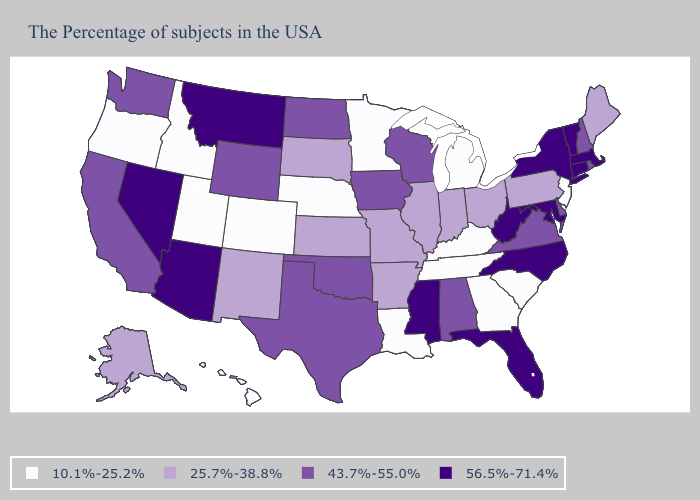What is the value of Arkansas?
Concise answer only. 25.7%-38.8%. Among the states that border Michigan , does Indiana have the lowest value?
Answer briefly. Yes. What is the value of Texas?
Write a very short answer. 43.7%-55.0%. Which states have the highest value in the USA?
Answer briefly. Massachusetts, Vermont, Connecticut, New York, Maryland, North Carolina, West Virginia, Florida, Mississippi, Montana, Arizona, Nevada. What is the lowest value in the USA?
Quick response, please. 10.1%-25.2%. What is the highest value in the USA?
Keep it brief. 56.5%-71.4%. What is the value of Kentucky?
Write a very short answer. 10.1%-25.2%. Name the states that have a value in the range 56.5%-71.4%?
Give a very brief answer. Massachusetts, Vermont, Connecticut, New York, Maryland, North Carolina, West Virginia, Florida, Mississippi, Montana, Arizona, Nevada. Does New York have the lowest value in the USA?
Concise answer only. No. What is the value of Maryland?
Give a very brief answer. 56.5%-71.4%. What is the lowest value in states that border Indiana?
Give a very brief answer. 10.1%-25.2%. Does New Hampshire have the same value as Washington?
Be succinct. Yes. What is the value of Texas?
Short answer required. 43.7%-55.0%. What is the highest value in the USA?
Quick response, please. 56.5%-71.4%. Name the states that have a value in the range 43.7%-55.0%?
Keep it brief. Rhode Island, New Hampshire, Delaware, Virginia, Alabama, Wisconsin, Iowa, Oklahoma, Texas, North Dakota, Wyoming, California, Washington. 